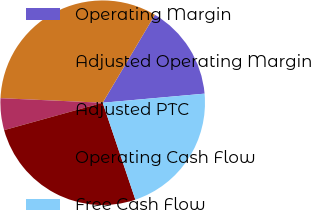Convert chart to OTSL. <chart><loc_0><loc_0><loc_500><loc_500><pie_chart><fcel>Operating Margin<fcel>Adjusted Operating Margin<fcel>Adjusted PTC<fcel>Operating Cash Flow<fcel>Free Cash Flow<nl><fcel>15.06%<fcel>32.82%<fcel>5.02%<fcel>25.87%<fcel>21.24%<nl></chart> 